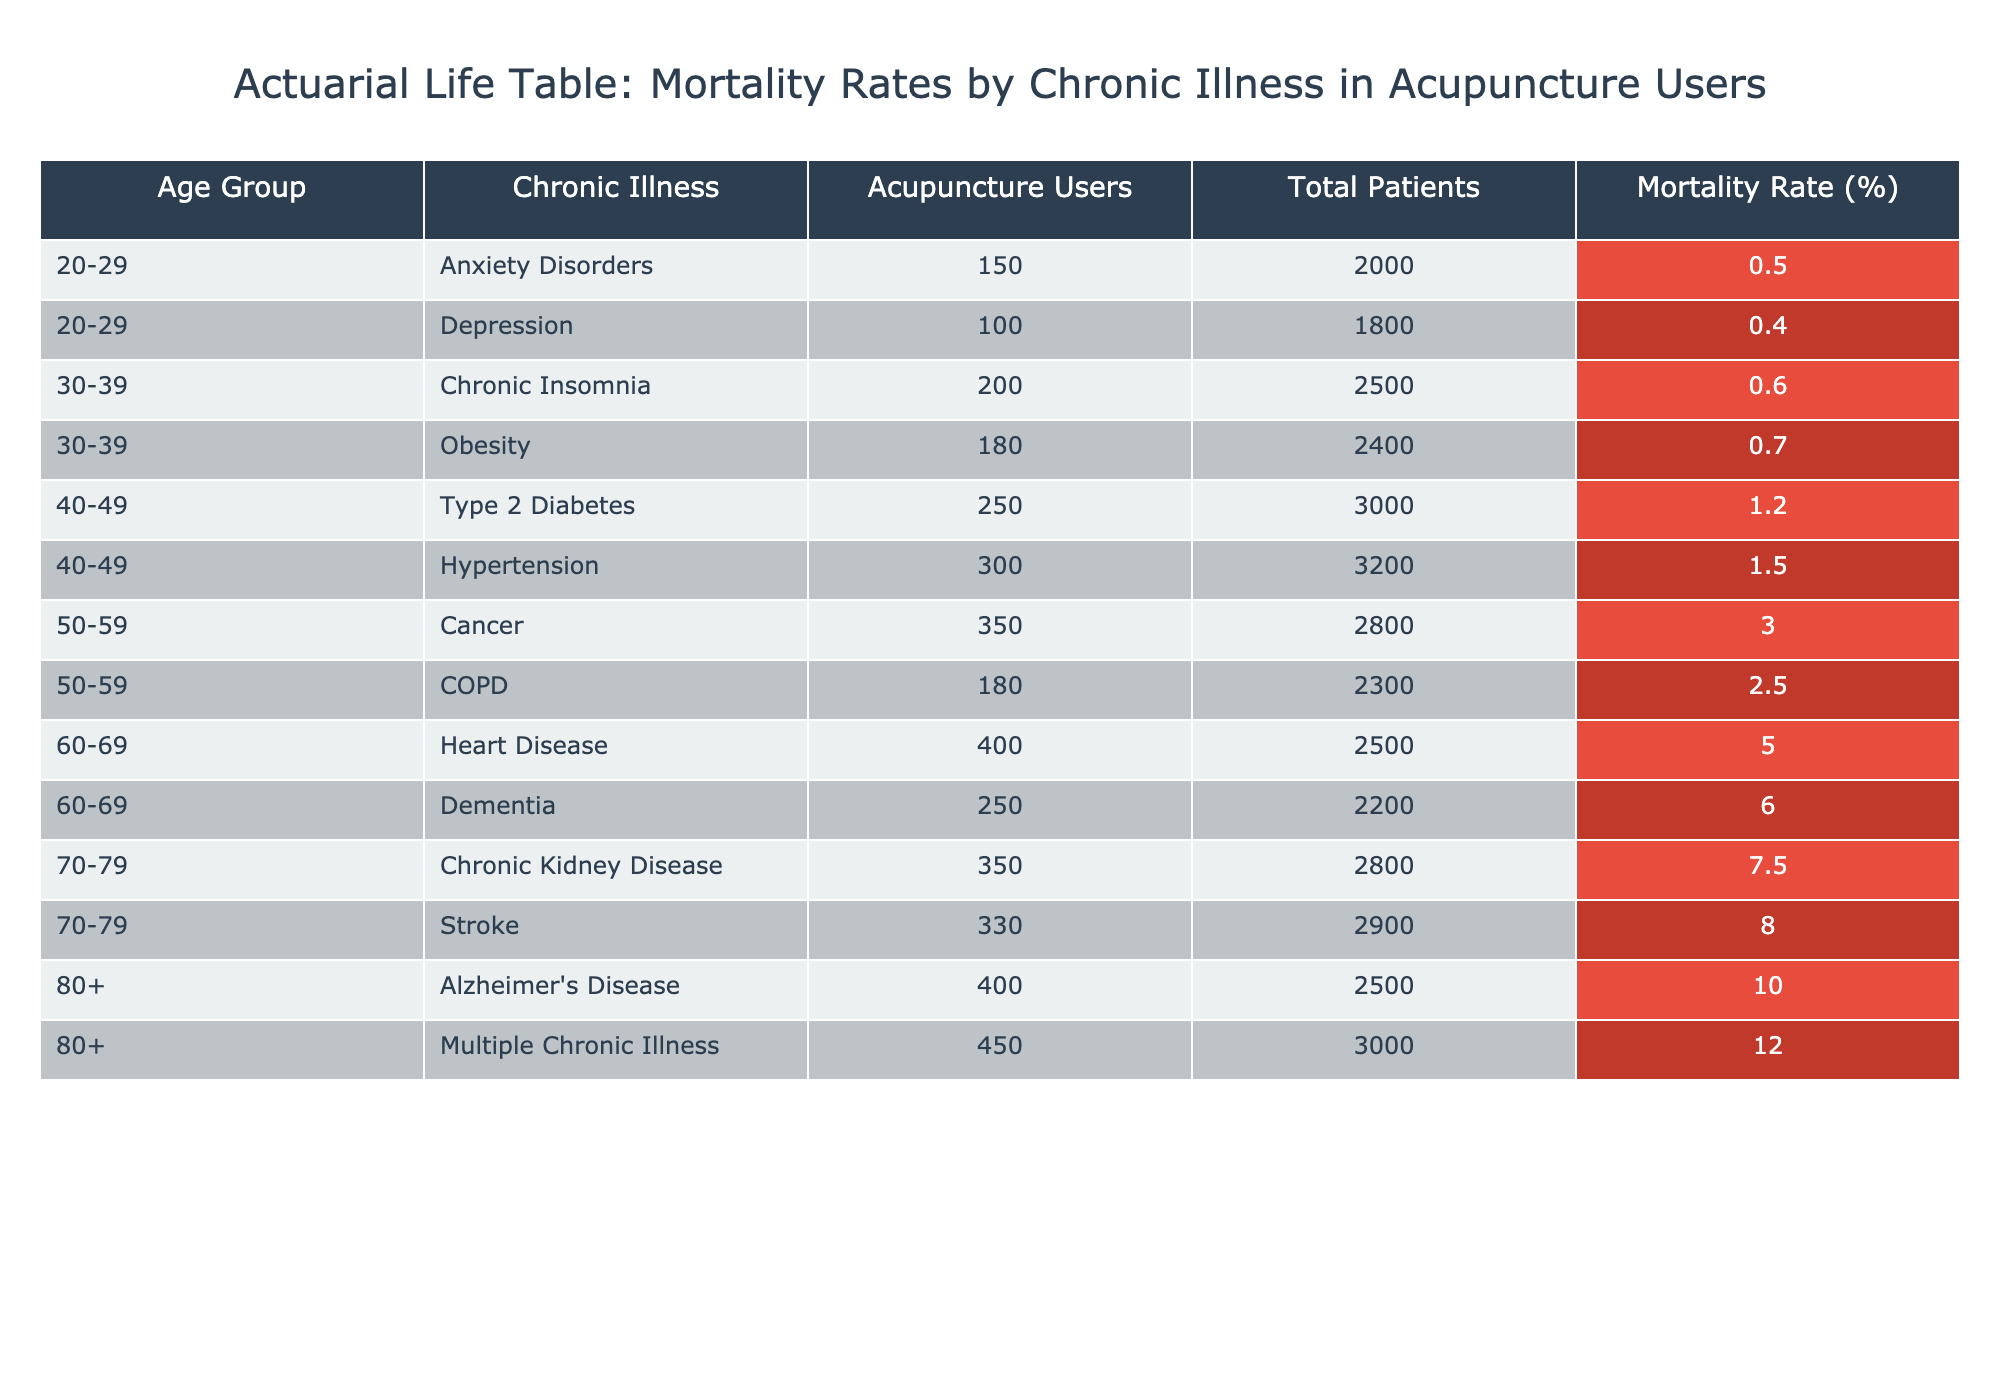What is the mortality rate for patients aged 50-59 with Cancer? From the data, under the age group of 50-59, the mortality rate for Cancer is listed as 3.0%.
Answer: 3.0% What is the total number of patients suffering from obesity and using acupuncture? From the data, the number of acupuncture users with Obesity in the 30-39 age group is 180.
Answer: 180 Which chronic illness among the age group 60-69 has the highest mortality rate? In the age group 60-69, Heart Disease has a mortality rate of 5.0% while Dementia has a higher rate of 6.0%. Therefore, Dementia has the highest mortality rate.
Answer: Dementia What is the average mortality rate for patients aged 70-79? The mortality rates for this age group are 7.5% (Chronic Kidney Disease) and 8.0% (Stroke). To calculate the average, we sum these rates (7.5 + 8.0 = 15.5) and divide by 2: 15.5/2 = 7.75%.
Answer: 7.75% Do patients aged 20-29 with Anxiety Disorders have a higher or lower mortality rate than those with Depression? The mortality rate for Anxiety Disorders is 0.5%, while for Depression, it is 0.4%. Thus, Anxiety Disorders have a higher mortality rate.
Answer: Higher What is the total number of patients over 80 years old with Multiple Chronic Illness? In the data, it states that there are 450 patients aged 80+ with Multiple Chronic Illness, as provided in the table.
Answer: 450 How does the mortality rate for patients with Type 2 Diabetes compare to those with Hypertension in the 40-49 age group? In the 40-49 age group, the mortality rate for Type 2 Diabetes is 1.2% and for Hypertension, it is 1.5%. Therefore, Hypertension has a higher mortality rate than Type 2 Diabetes.
Answer: Hypertension has a higher rate What is the combined total of acupuncture users across all age groups for Chronic Insomnia and Depression? For Chronic Insomnia, the total number of acupuncture users is 200 (30-39 age group), and for Depression, it is 100 (20-29 age group). Adding these values together gives us 200 + 100 = 300.
Answer: 300 Is the mortality rate for patients aged 60-69 with Heart Disease lower than the overall mortality rate for patients aged 80 and older? The mortality rate for Heart Disease in the 60-69 age group is 5.0%, while for those aged 80+, the rate is 10.0%. Thus, the heart disease mortality rate is lower.
Answer: Yes 